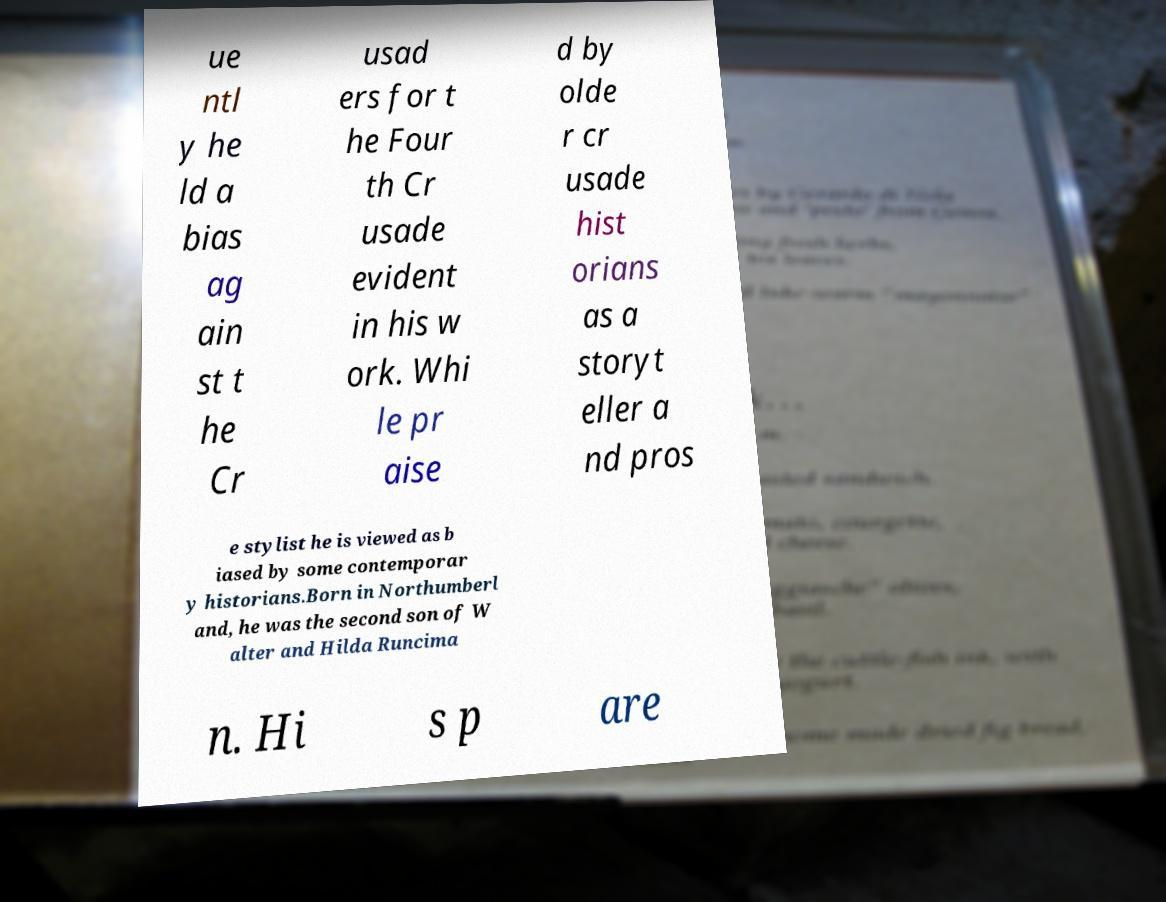Please read and relay the text visible in this image. What does it say? ue ntl y he ld a bias ag ain st t he Cr usad ers for t he Four th Cr usade evident in his w ork. Whi le pr aise d by olde r cr usade hist orians as a storyt eller a nd pros e stylist he is viewed as b iased by some contemporar y historians.Born in Northumberl and, he was the second son of W alter and Hilda Runcima n. Hi s p are 